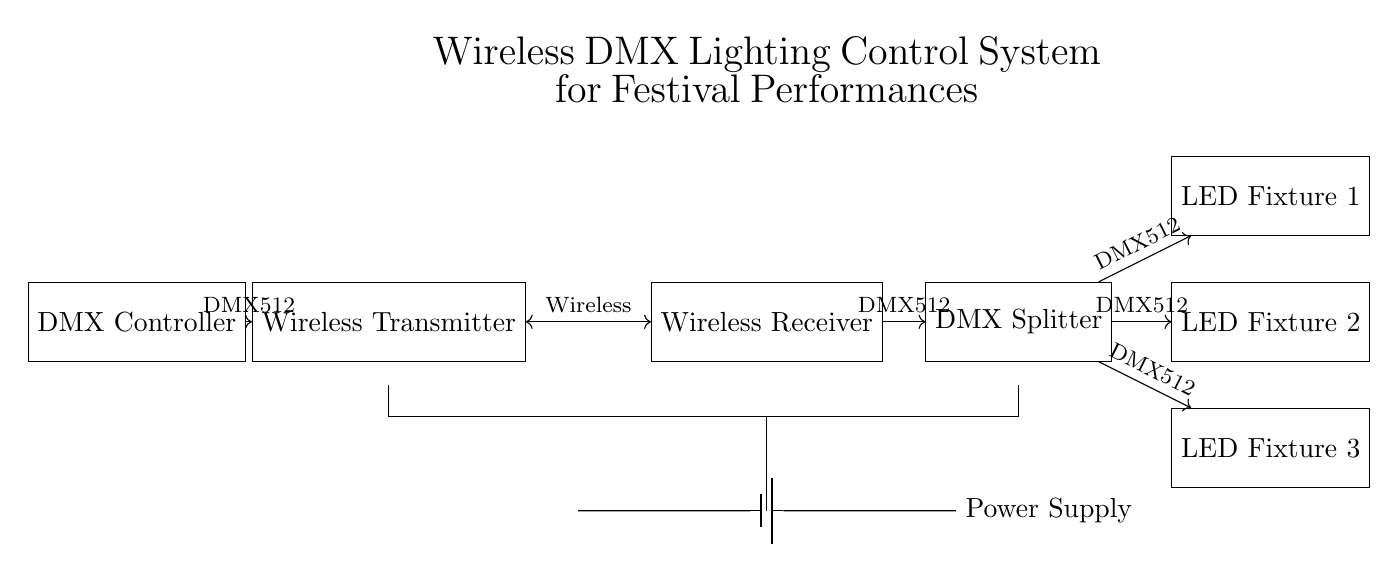What is the primary input for the DMX Controller? The DMX Controller receives a DMX512 input signal, which is the standard protocol used to control lighting systems.
Answer: DMX512 What type of signal is sent between the Transmitter and Receiver? The connection between the Transmitter and Receiver is wireless, allowing data to be transmitted without physical wires.
Answer: Wireless How many LED fixtures are connected in this circuit? The diagram shows three LED fixtures, indicating the total number of fixtures that can be controlled via the DMX system.
Answer: Three What component splits the DMX signal to multiple outputs? The DMX Splitter is specifically designed to divide the incoming DMX signal into multiple outputs, enabling control of various fixtures simultaneously.
Answer: DMX Splitter What is the function of the Wireless Transmitter? The Wireless Transmitter is responsible for sending the DMX512 signals wirelessly from the controller to the receiver, facilitating remote lighting control.
Answer: Send DMX512 signals How is power supplied to the system? The system is powered by a battery, which provides the necessary voltage and current to operate the DMX components and fixtures.
Answer: Battery Which component acts as an intermediary for DMX signals to the LED fixtures? The DMX Splitter serves as the intermediary, distributing the incoming DMX512 signal to each connected LED fixture for control purposes.
Answer: DMX Splitter 